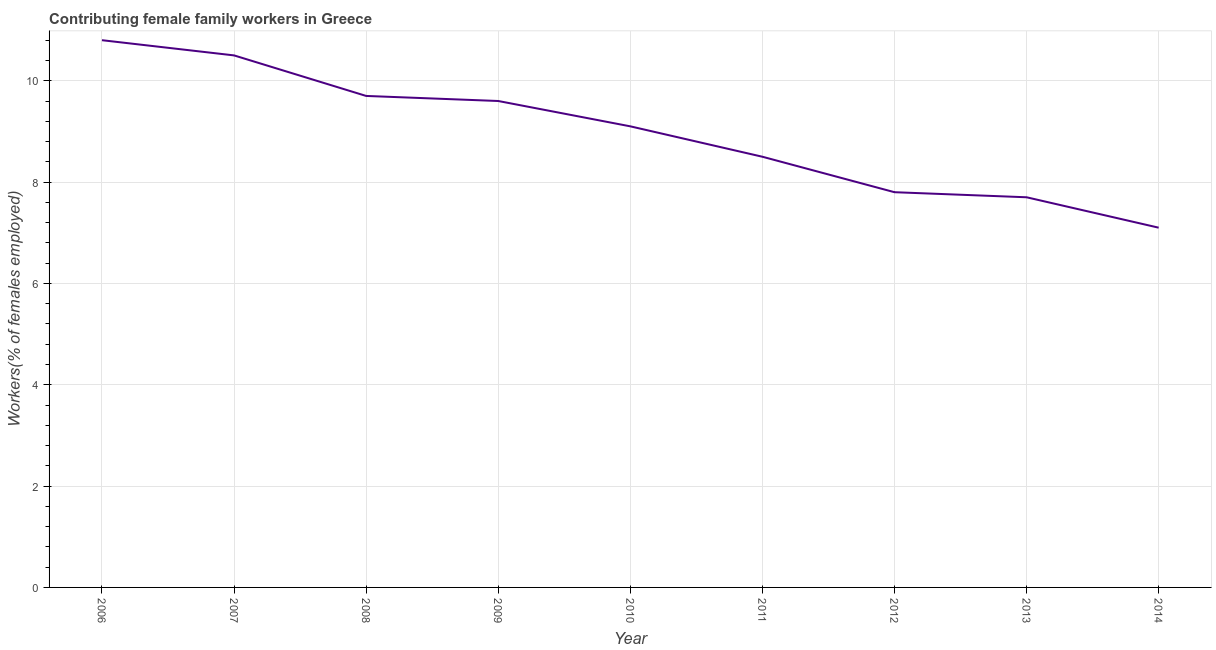Across all years, what is the maximum contributing female family workers?
Offer a very short reply. 10.8. Across all years, what is the minimum contributing female family workers?
Give a very brief answer. 7.1. What is the sum of the contributing female family workers?
Provide a short and direct response. 80.8. What is the difference between the contributing female family workers in 2013 and 2014?
Your answer should be very brief. 0.6. What is the average contributing female family workers per year?
Keep it short and to the point. 8.98. What is the median contributing female family workers?
Provide a short and direct response. 9.1. In how many years, is the contributing female family workers greater than 1.2000000000000002 %?
Offer a very short reply. 9. What is the ratio of the contributing female family workers in 2012 to that in 2013?
Give a very brief answer. 1.01. What is the difference between the highest and the second highest contributing female family workers?
Your answer should be very brief. 0.3. What is the difference between the highest and the lowest contributing female family workers?
Your response must be concise. 3.7. In how many years, is the contributing female family workers greater than the average contributing female family workers taken over all years?
Keep it short and to the point. 5. Does the contributing female family workers monotonically increase over the years?
Keep it short and to the point. No. How many lines are there?
Provide a short and direct response. 1. How many years are there in the graph?
Make the answer very short. 9. What is the difference between two consecutive major ticks on the Y-axis?
Ensure brevity in your answer.  2. Are the values on the major ticks of Y-axis written in scientific E-notation?
Provide a succinct answer. No. What is the title of the graph?
Provide a short and direct response. Contributing female family workers in Greece. What is the label or title of the X-axis?
Offer a terse response. Year. What is the label or title of the Y-axis?
Make the answer very short. Workers(% of females employed). What is the Workers(% of females employed) in 2006?
Keep it short and to the point. 10.8. What is the Workers(% of females employed) of 2008?
Provide a short and direct response. 9.7. What is the Workers(% of females employed) in 2009?
Give a very brief answer. 9.6. What is the Workers(% of females employed) in 2010?
Offer a very short reply. 9.1. What is the Workers(% of females employed) of 2011?
Make the answer very short. 8.5. What is the Workers(% of females employed) of 2012?
Give a very brief answer. 7.8. What is the Workers(% of females employed) of 2013?
Give a very brief answer. 7.7. What is the Workers(% of females employed) of 2014?
Your answer should be compact. 7.1. What is the difference between the Workers(% of females employed) in 2006 and 2008?
Provide a succinct answer. 1.1. What is the difference between the Workers(% of females employed) in 2006 and 2009?
Your response must be concise. 1.2. What is the difference between the Workers(% of females employed) in 2006 and 2012?
Keep it short and to the point. 3. What is the difference between the Workers(% of females employed) in 2006 and 2014?
Give a very brief answer. 3.7. What is the difference between the Workers(% of females employed) in 2007 and 2009?
Give a very brief answer. 0.9. What is the difference between the Workers(% of females employed) in 2007 and 2010?
Offer a terse response. 1.4. What is the difference between the Workers(% of females employed) in 2007 and 2012?
Provide a short and direct response. 2.7. What is the difference between the Workers(% of females employed) in 2007 and 2014?
Your response must be concise. 3.4. What is the difference between the Workers(% of females employed) in 2008 and 2010?
Your answer should be compact. 0.6. What is the difference between the Workers(% of females employed) in 2008 and 2012?
Your response must be concise. 1.9. What is the difference between the Workers(% of females employed) in 2010 and 2012?
Give a very brief answer. 1.3. What is the difference between the Workers(% of females employed) in 2010 and 2013?
Offer a terse response. 1.4. What is the difference between the Workers(% of females employed) in 2011 and 2013?
Your answer should be compact. 0.8. What is the difference between the Workers(% of females employed) in 2011 and 2014?
Ensure brevity in your answer.  1.4. What is the difference between the Workers(% of females employed) in 2013 and 2014?
Offer a terse response. 0.6. What is the ratio of the Workers(% of females employed) in 2006 to that in 2007?
Offer a terse response. 1.03. What is the ratio of the Workers(% of females employed) in 2006 to that in 2008?
Offer a very short reply. 1.11. What is the ratio of the Workers(% of females employed) in 2006 to that in 2009?
Ensure brevity in your answer.  1.12. What is the ratio of the Workers(% of females employed) in 2006 to that in 2010?
Offer a terse response. 1.19. What is the ratio of the Workers(% of females employed) in 2006 to that in 2011?
Keep it short and to the point. 1.27. What is the ratio of the Workers(% of females employed) in 2006 to that in 2012?
Your answer should be very brief. 1.39. What is the ratio of the Workers(% of females employed) in 2006 to that in 2013?
Offer a very short reply. 1.4. What is the ratio of the Workers(% of females employed) in 2006 to that in 2014?
Offer a terse response. 1.52. What is the ratio of the Workers(% of females employed) in 2007 to that in 2008?
Your response must be concise. 1.08. What is the ratio of the Workers(% of females employed) in 2007 to that in 2009?
Offer a terse response. 1.09. What is the ratio of the Workers(% of females employed) in 2007 to that in 2010?
Offer a very short reply. 1.15. What is the ratio of the Workers(% of females employed) in 2007 to that in 2011?
Provide a succinct answer. 1.24. What is the ratio of the Workers(% of females employed) in 2007 to that in 2012?
Provide a succinct answer. 1.35. What is the ratio of the Workers(% of females employed) in 2007 to that in 2013?
Keep it short and to the point. 1.36. What is the ratio of the Workers(% of females employed) in 2007 to that in 2014?
Your response must be concise. 1.48. What is the ratio of the Workers(% of females employed) in 2008 to that in 2009?
Ensure brevity in your answer.  1.01. What is the ratio of the Workers(% of females employed) in 2008 to that in 2010?
Your response must be concise. 1.07. What is the ratio of the Workers(% of females employed) in 2008 to that in 2011?
Your answer should be very brief. 1.14. What is the ratio of the Workers(% of females employed) in 2008 to that in 2012?
Offer a very short reply. 1.24. What is the ratio of the Workers(% of females employed) in 2008 to that in 2013?
Ensure brevity in your answer.  1.26. What is the ratio of the Workers(% of females employed) in 2008 to that in 2014?
Your response must be concise. 1.37. What is the ratio of the Workers(% of females employed) in 2009 to that in 2010?
Your answer should be compact. 1.05. What is the ratio of the Workers(% of females employed) in 2009 to that in 2011?
Make the answer very short. 1.13. What is the ratio of the Workers(% of females employed) in 2009 to that in 2012?
Offer a very short reply. 1.23. What is the ratio of the Workers(% of females employed) in 2009 to that in 2013?
Your answer should be very brief. 1.25. What is the ratio of the Workers(% of females employed) in 2009 to that in 2014?
Make the answer very short. 1.35. What is the ratio of the Workers(% of females employed) in 2010 to that in 2011?
Offer a very short reply. 1.07. What is the ratio of the Workers(% of females employed) in 2010 to that in 2012?
Provide a short and direct response. 1.17. What is the ratio of the Workers(% of females employed) in 2010 to that in 2013?
Your answer should be very brief. 1.18. What is the ratio of the Workers(% of females employed) in 2010 to that in 2014?
Your answer should be very brief. 1.28. What is the ratio of the Workers(% of females employed) in 2011 to that in 2012?
Your answer should be very brief. 1.09. What is the ratio of the Workers(% of females employed) in 2011 to that in 2013?
Your answer should be very brief. 1.1. What is the ratio of the Workers(% of females employed) in 2011 to that in 2014?
Offer a very short reply. 1.2. What is the ratio of the Workers(% of females employed) in 2012 to that in 2014?
Give a very brief answer. 1.1. What is the ratio of the Workers(% of females employed) in 2013 to that in 2014?
Provide a succinct answer. 1.08. 